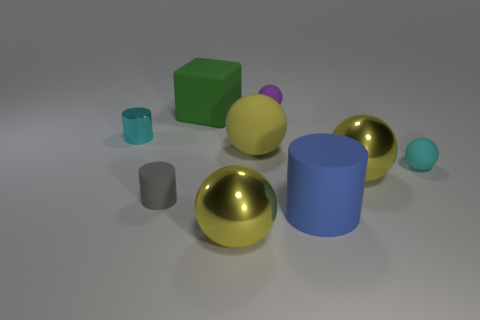Can you tell me what the lighting in the scene suggests about the setting? The overhead lighting with subtle shadows indicates an indoor setting with a soft, diffuse light source, possibly situated above the scene creating a calm and neutral atmosphere. 